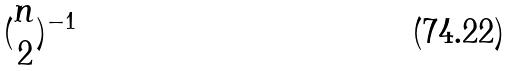Convert formula to latex. <formula><loc_0><loc_0><loc_500><loc_500>( \begin{matrix} n \\ 2 \end{matrix} ) ^ { - 1 }</formula> 